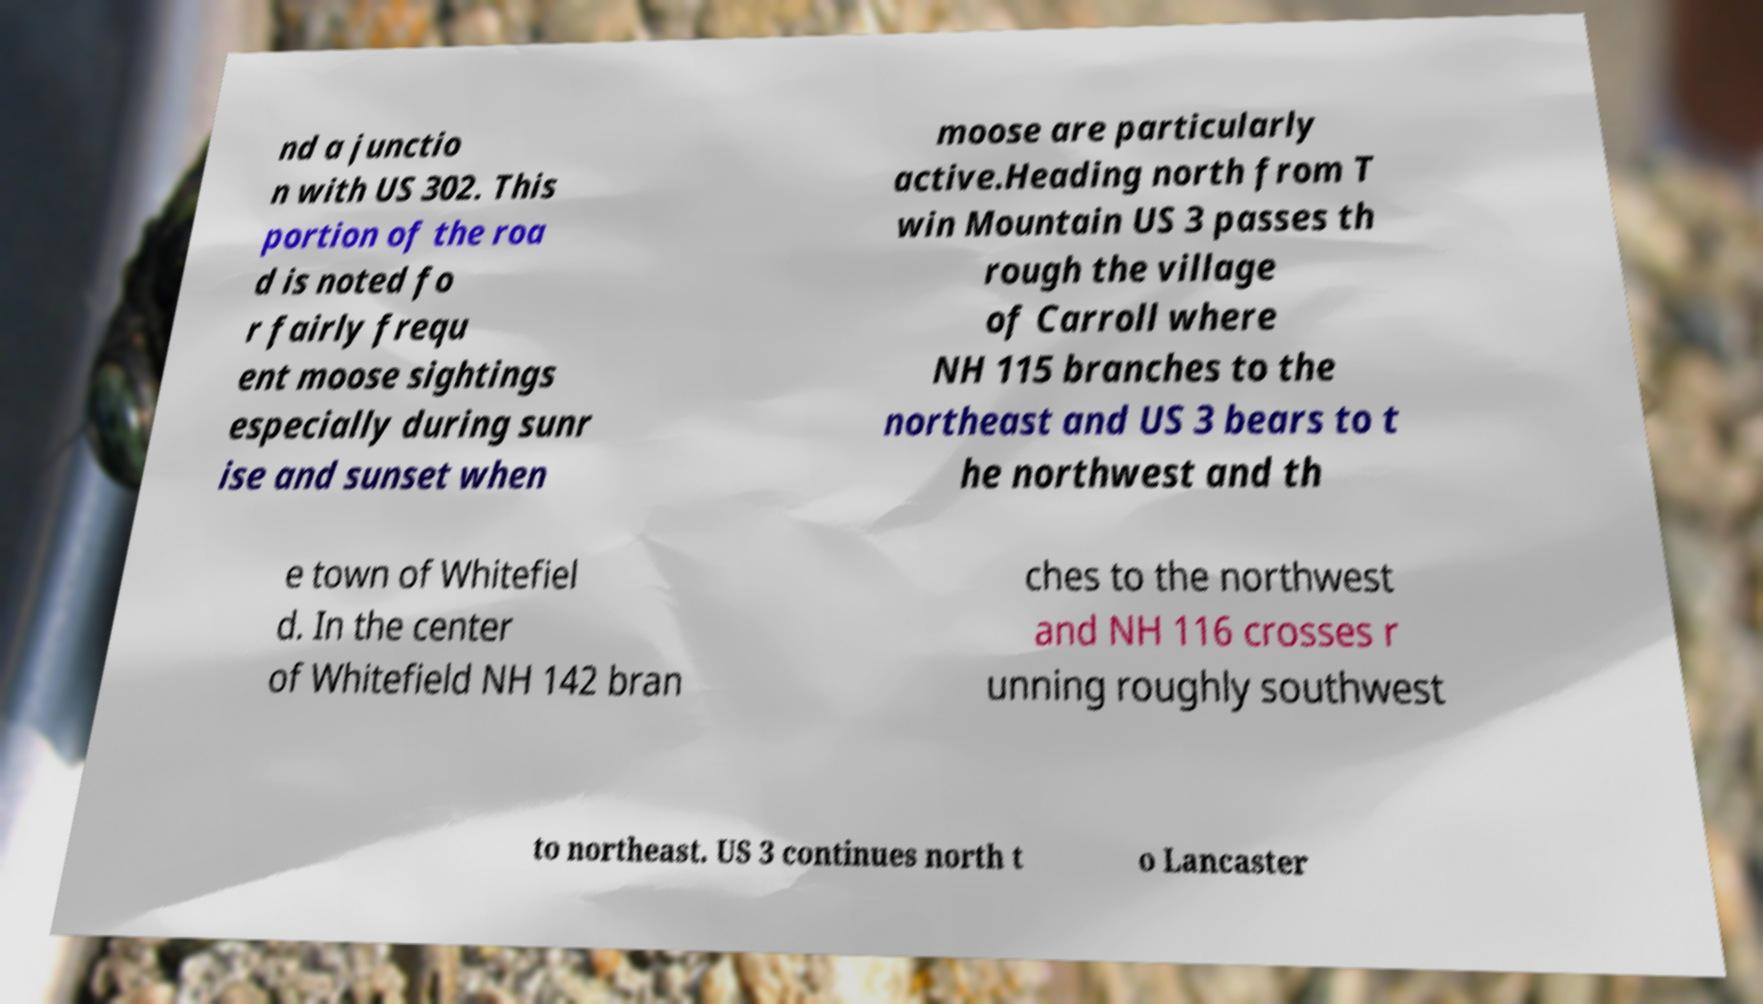There's text embedded in this image that I need extracted. Can you transcribe it verbatim? nd a junctio n with US 302. This portion of the roa d is noted fo r fairly frequ ent moose sightings especially during sunr ise and sunset when moose are particularly active.Heading north from T win Mountain US 3 passes th rough the village of Carroll where NH 115 branches to the northeast and US 3 bears to t he northwest and th e town of Whitefiel d. In the center of Whitefield NH 142 bran ches to the northwest and NH 116 crosses r unning roughly southwest to northeast. US 3 continues north t o Lancaster 